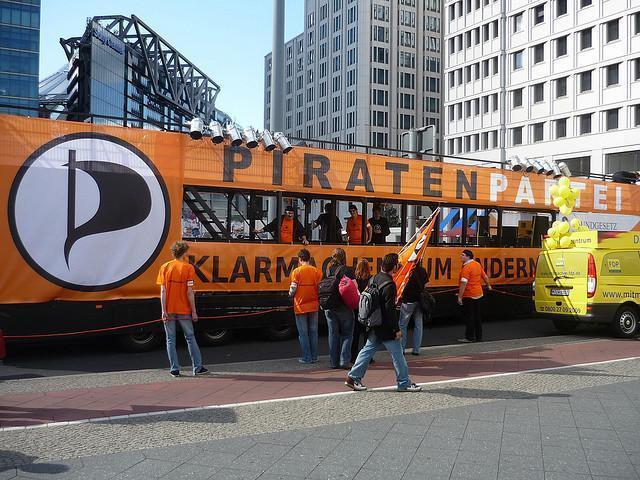Why are the people wearing orange shirts?
Choose the right answer from the provided options to respond to the question.
Options: Costume, warmth, fashion, uniform. Uniform. What fun item can be seen in the photo?
Pick the correct solution from the four options below to address the question.
Options: Ponies, candy, rides, balloons. Balloons. 